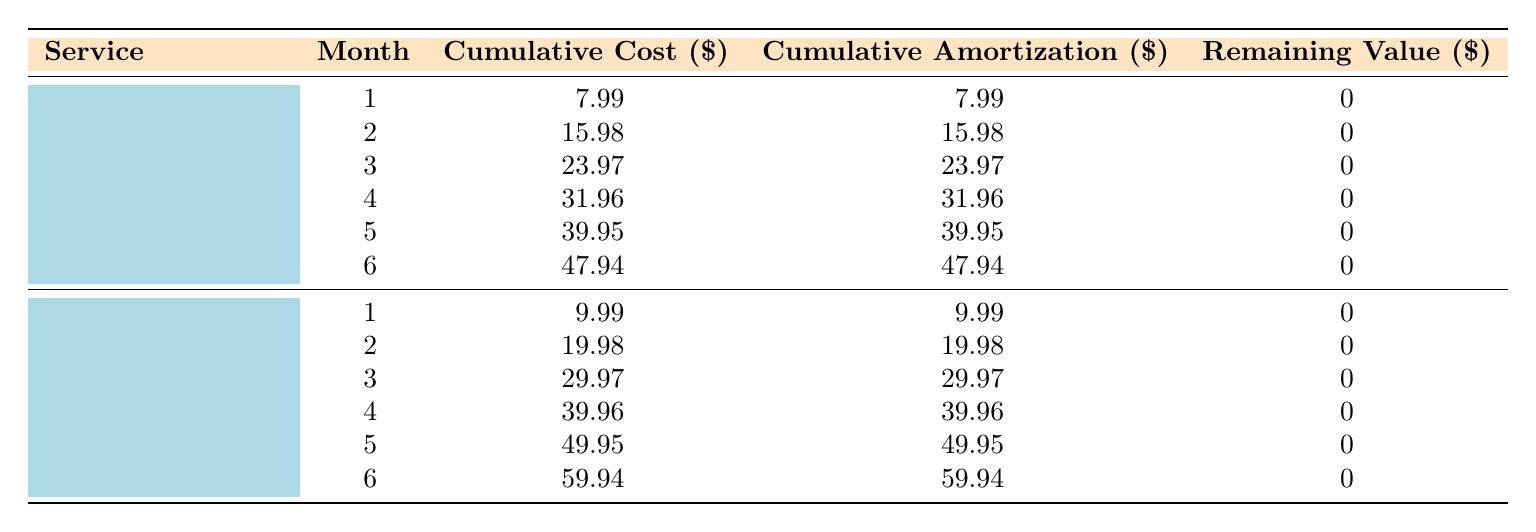What is the monthly fee for Disney+? The table shows that the monthly fee for Disney+ is listed directly under the corresponding service name. It is 7.99.
Answer: 7.99 What is the cumulative cost for Spotify Premium in month 6? According to the amortization schedule for Spotify Premium, the cumulative cost in month 6 is specifically mentioned in the table as 59.94.
Answer: 59.94 Did Disney+ have any remaining value at the end of the subscription length? The remaining value for all months in the amortization schedule for Disney+ is consistently noted as 0, indicating there was no remaining value at the end of the subscription.
Answer: Yes What is the total cumulative cost for both services in month 12? From the table, the cumulative cost for Disney+ in month 12 is 95.88, and for Spotify Premium it is 119.88. Adding these two values gives total cumulative cost of 95.88 + 119.88 = 215.76.
Answer: 215.76 Which service has a higher cumulative amortization in month 10? The cumulative amortization for Disney+ in month 10 is 79.90, while for Spotify Premium it's 99.90. Comparing these two values, Spotify Premium has the higher cumulative amortization.
Answer: Spotify Premium What is the average cumulative cost for Disney+ over the first 6 months? To find the average, sum the cumulative costs for the first 6 months of Disney+ and divide by 6: (7.99 + 15.98 + 23.97 + 31.96 + 39.95 + 47.94) / 6 = 31.80.
Answer: 31.80 Did the cumulative amortization for Spotify Premium change from month 1 to month 12? Yes, the cumulative amortization for Spotify Premium is 9.99 in month 1 and increases to 119.88 in month 12, indicating a change over the subscription period.
Answer: Yes What is the cumulative cost difference between month 11 and month 12 for Disney+? The cumulative cost for Disney+ in month 11 is 87.89, and in month 12 it is 95.88. The difference is calculated as 95.88 - 87.89 = 7.99.
Answer: 7.99 What is the total amount spent on subscription services over the full length of both services? The total amount for Disney+ is 95.88, and for Spotify Premium it is 119.88. Adding these amounts, the total spent is 95.88 + 119.88 = 215.76.
Answer: 215.76 